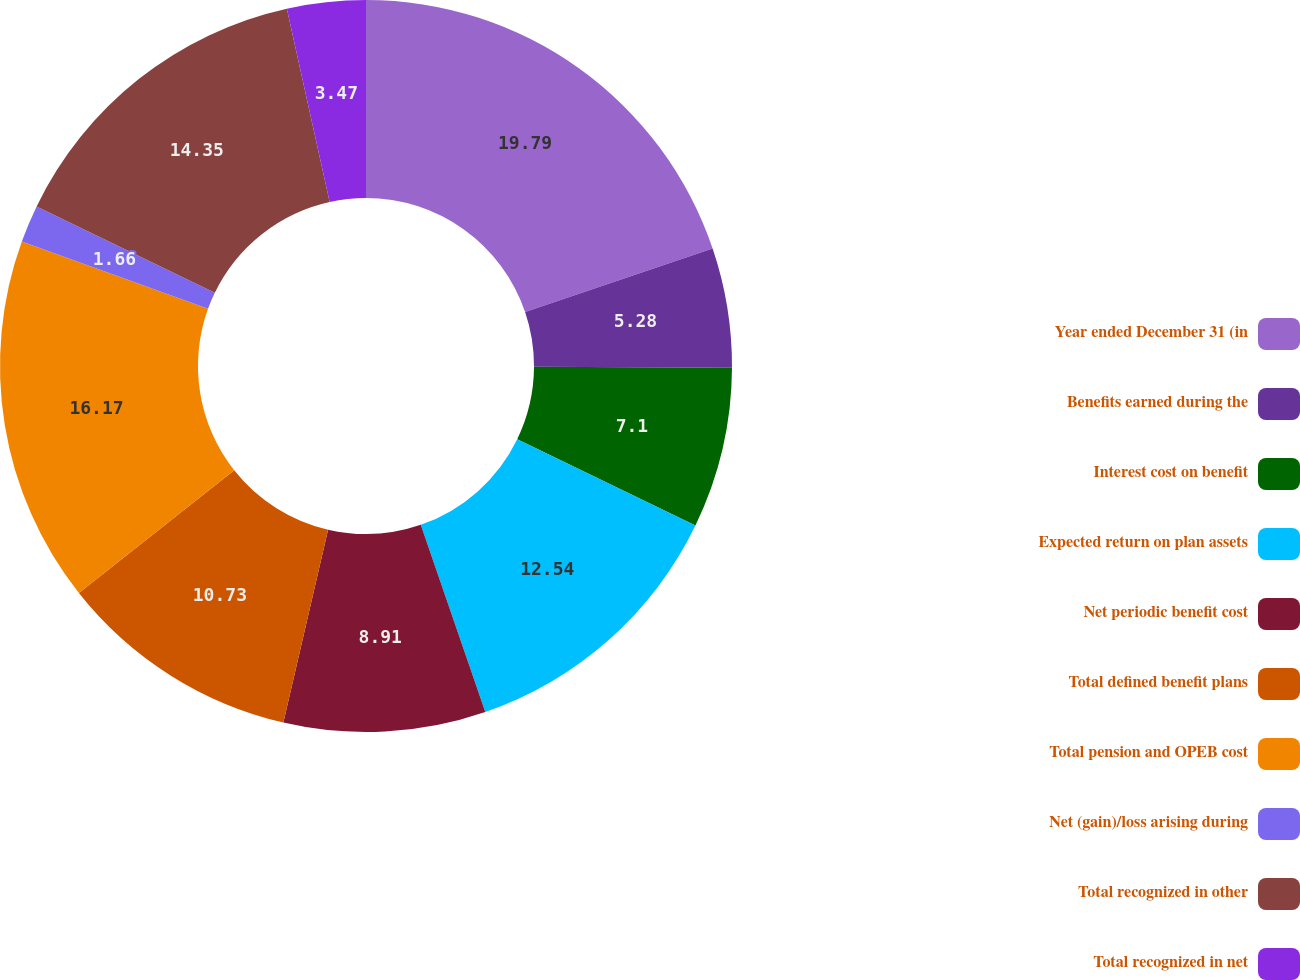Convert chart to OTSL. <chart><loc_0><loc_0><loc_500><loc_500><pie_chart><fcel>Year ended December 31 (in<fcel>Benefits earned during the<fcel>Interest cost on benefit<fcel>Expected return on plan assets<fcel>Net periodic benefit cost<fcel>Total defined benefit plans<fcel>Total pension and OPEB cost<fcel>Net (gain)/loss arising during<fcel>Total recognized in other<fcel>Total recognized in net<nl><fcel>19.8%<fcel>5.28%<fcel>7.1%<fcel>12.54%<fcel>8.91%<fcel>10.73%<fcel>16.17%<fcel>1.66%<fcel>14.35%<fcel>3.47%<nl></chart> 